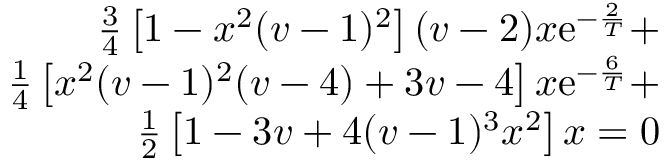<formula> <loc_0><loc_0><loc_500><loc_500>\begin{array} { r l } { \frac { 3 } { 4 } \left [ 1 - x ^ { 2 } ( v - 1 ) ^ { 2 } \right ] ( v - 2 ) x e ^ { - \frac { 2 } { T } } + } \\ { \frac { 1 } { 4 } \left [ x ^ { 2 } ( v - 1 ) ^ { 2 } ( v - 4 ) + 3 v - 4 \right ] x e ^ { - \frac { 6 } { T } } + } \\ { \frac { 1 } { 2 } \left [ 1 - 3 v + 4 ( v - 1 ) ^ { 3 } x ^ { 2 } \right ] x = 0 } \end{array}</formula> 